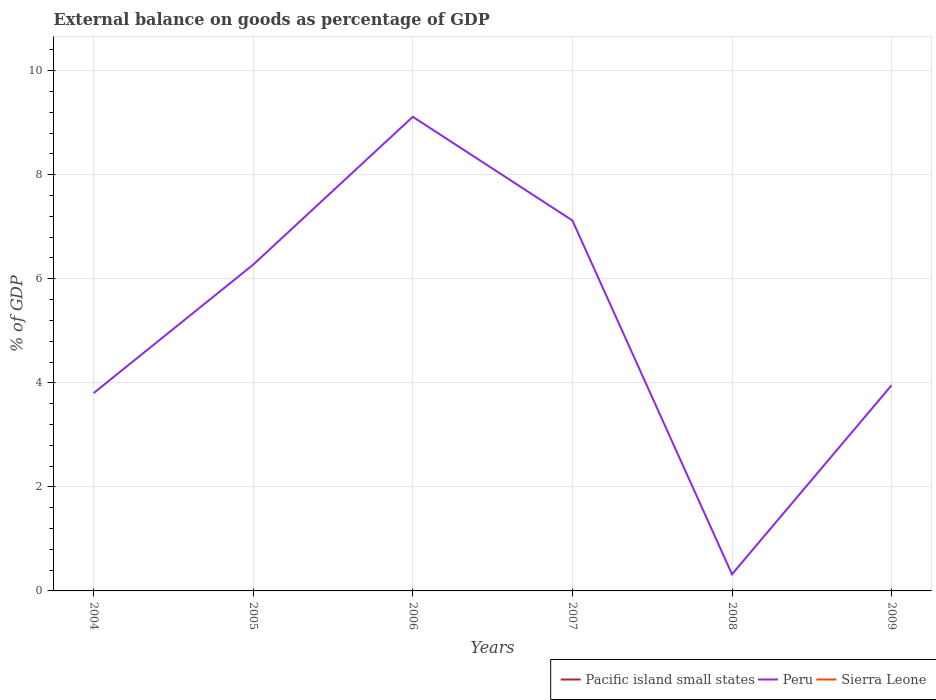Across all years, what is the maximum external balance on goods as percentage of GDP in Peru?
Give a very brief answer. 0.32. What is the total external balance on goods as percentage of GDP in Peru in the graph?
Your answer should be very brief. 8.79. What is the difference between the highest and the second highest external balance on goods as percentage of GDP in Peru?
Your answer should be very brief. 8.79. What is the difference between the highest and the lowest external balance on goods as percentage of GDP in Peru?
Keep it short and to the point. 3. How many lines are there?
Ensure brevity in your answer.  1. How many years are there in the graph?
Make the answer very short. 6. What is the difference between two consecutive major ticks on the Y-axis?
Your answer should be very brief. 2. Are the values on the major ticks of Y-axis written in scientific E-notation?
Offer a very short reply. No. How many legend labels are there?
Provide a succinct answer. 3. What is the title of the graph?
Offer a very short reply. External balance on goods as percentage of GDP. Does "Guyana" appear as one of the legend labels in the graph?
Your answer should be very brief. No. What is the label or title of the X-axis?
Your answer should be compact. Years. What is the label or title of the Y-axis?
Your response must be concise. % of GDP. What is the % of GDP in Peru in 2004?
Your response must be concise. 3.8. What is the % of GDP of Sierra Leone in 2004?
Ensure brevity in your answer.  0. What is the % of GDP of Peru in 2005?
Provide a short and direct response. 6.27. What is the % of GDP in Pacific island small states in 2006?
Ensure brevity in your answer.  0. What is the % of GDP of Peru in 2006?
Give a very brief answer. 9.11. What is the % of GDP of Sierra Leone in 2006?
Provide a succinct answer. 0. What is the % of GDP in Pacific island small states in 2007?
Make the answer very short. 0. What is the % of GDP of Peru in 2007?
Your response must be concise. 7.12. What is the % of GDP of Sierra Leone in 2007?
Offer a very short reply. 0. What is the % of GDP in Pacific island small states in 2008?
Give a very brief answer. 0. What is the % of GDP in Peru in 2008?
Offer a very short reply. 0.32. What is the % of GDP of Peru in 2009?
Your answer should be compact. 3.95. Across all years, what is the maximum % of GDP of Peru?
Offer a terse response. 9.11. Across all years, what is the minimum % of GDP of Peru?
Your answer should be compact. 0.32. What is the total % of GDP in Pacific island small states in the graph?
Provide a succinct answer. 0. What is the total % of GDP of Peru in the graph?
Make the answer very short. 30.58. What is the difference between the % of GDP of Peru in 2004 and that in 2005?
Your response must be concise. -2.47. What is the difference between the % of GDP of Peru in 2004 and that in 2006?
Offer a very short reply. -5.31. What is the difference between the % of GDP in Peru in 2004 and that in 2007?
Provide a short and direct response. -3.32. What is the difference between the % of GDP in Peru in 2004 and that in 2008?
Your answer should be very brief. 3.48. What is the difference between the % of GDP in Peru in 2004 and that in 2009?
Your response must be concise. -0.15. What is the difference between the % of GDP of Peru in 2005 and that in 2006?
Provide a short and direct response. -2.84. What is the difference between the % of GDP in Peru in 2005 and that in 2007?
Give a very brief answer. -0.85. What is the difference between the % of GDP of Peru in 2005 and that in 2008?
Make the answer very short. 5.95. What is the difference between the % of GDP in Peru in 2005 and that in 2009?
Ensure brevity in your answer.  2.32. What is the difference between the % of GDP of Peru in 2006 and that in 2007?
Offer a very short reply. 1.99. What is the difference between the % of GDP of Peru in 2006 and that in 2008?
Offer a very short reply. 8.79. What is the difference between the % of GDP of Peru in 2006 and that in 2009?
Make the answer very short. 5.16. What is the difference between the % of GDP in Peru in 2007 and that in 2008?
Your answer should be very brief. 6.8. What is the difference between the % of GDP of Peru in 2007 and that in 2009?
Offer a very short reply. 3.17. What is the difference between the % of GDP in Peru in 2008 and that in 2009?
Offer a terse response. -3.63. What is the average % of GDP in Pacific island small states per year?
Make the answer very short. 0. What is the average % of GDP of Peru per year?
Your response must be concise. 5.1. What is the ratio of the % of GDP of Peru in 2004 to that in 2005?
Provide a short and direct response. 0.61. What is the ratio of the % of GDP of Peru in 2004 to that in 2006?
Your answer should be compact. 0.42. What is the ratio of the % of GDP in Peru in 2004 to that in 2007?
Keep it short and to the point. 0.53. What is the ratio of the % of GDP of Peru in 2004 to that in 2008?
Provide a succinct answer. 11.87. What is the ratio of the % of GDP in Peru in 2004 to that in 2009?
Offer a very short reply. 0.96. What is the ratio of the % of GDP in Peru in 2005 to that in 2006?
Keep it short and to the point. 0.69. What is the ratio of the % of GDP in Peru in 2005 to that in 2007?
Make the answer very short. 0.88. What is the ratio of the % of GDP of Peru in 2005 to that in 2008?
Offer a very short reply. 19.58. What is the ratio of the % of GDP of Peru in 2005 to that in 2009?
Your response must be concise. 1.59. What is the ratio of the % of GDP in Peru in 2006 to that in 2007?
Provide a succinct answer. 1.28. What is the ratio of the % of GDP in Peru in 2006 to that in 2008?
Your answer should be compact. 28.45. What is the ratio of the % of GDP in Peru in 2006 to that in 2009?
Your response must be concise. 2.31. What is the ratio of the % of GDP of Peru in 2007 to that in 2008?
Provide a short and direct response. 22.23. What is the ratio of the % of GDP in Peru in 2007 to that in 2009?
Make the answer very short. 1.8. What is the ratio of the % of GDP in Peru in 2008 to that in 2009?
Offer a terse response. 0.08. What is the difference between the highest and the second highest % of GDP in Peru?
Make the answer very short. 1.99. What is the difference between the highest and the lowest % of GDP of Peru?
Give a very brief answer. 8.79. 